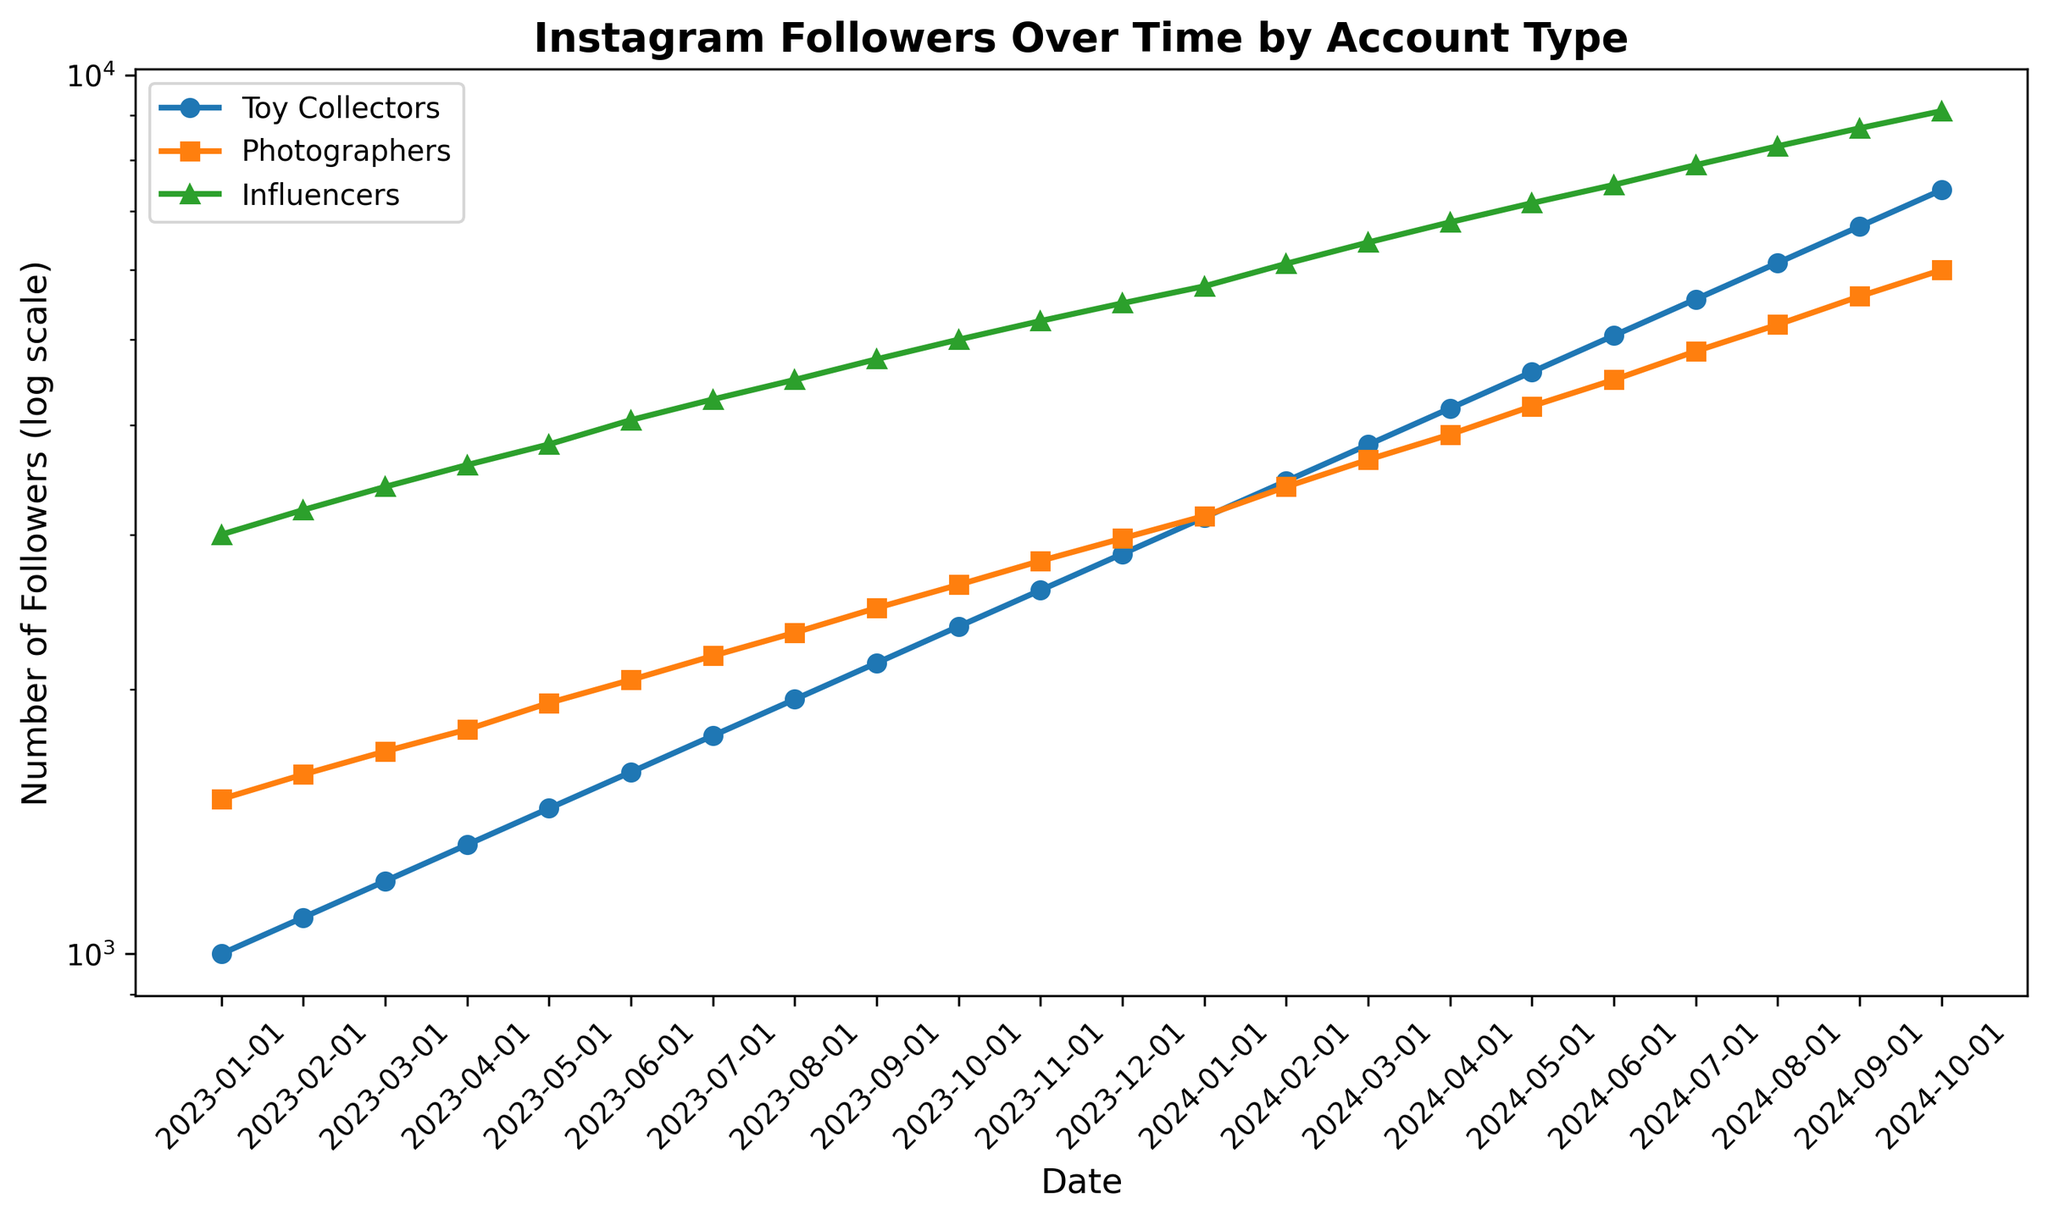How does the number of followers of Toy Collectors and Photographers compare in June 2024? To compare the number of followers of Toy Collectors and Photographers in June 2024, we look at their respective values. Toy Collectors have 5053 followers and Photographers have 4500 followers. By comparing these two values, we can see that Toy Collectors have more followers.
Answer: Toy Collectors have more followers Which account type experienced the highest growth rate from January 2023 to October 2024? To determine the highest growth rate, we calculate the percentage increase for each account type from January 2023 to October 2024. For Toy Collectors: ((7398 - 1000) / 1000) * 100 = 639.8%. For Photographers: ((6000 - 1500) / 1500) * 100 = 300%. For Influencers: ((9100 - 3000) / 3000) * 100 = 203.3%. Toy Collectors have the highest growth rate.
Answer: Toy Collectors What is the overall trend for the number of followers for all account types from January 2023 to October 2024? The trend can be observed by examining the slopes of the lines for each account type. All three lines show an upward trend on a log scale, indicating that the number of followers for Toy Collectors, Photographers, and Influencers is increasing over time.
Answer: Increasing On which month did Influencers cross the 5000 follower mark? Looking at the number of followers for Influencers, we see they crossed the 5000 follower mark in October 2023 when they reached 5000 followers.
Answer: October 2023 In which period did Toy Collectors see their highest monthly gain in followers? To find the highest monthly gain, we compare the increases in followers for each month. From February 2024 (3451) to March 2024 (3796) is an increase of 345 followers, which is the highest gain observed.
Answer: February to March 2024 Which account type has the steepest curve on the log scale plot? The steepness of the curve indicates the growth rate on a log scale. By observing the slopes visually, Toy Collectors have the steepest curve, indicating the fastest growth rate on a log scale.
Answer: Toy Collectors What is the difference in the number of followers between Photographers and Influencers in September 2023? In September 2023, Photographers have 2475 followers and Influencers have 4750 followers. The difference is 4750 - 2475 = 2275.
Answer: 2275 How many total followers did all account types have in January 2024? The total number of followers for all account types in January 2024 is the sum of Toy Collectors, Photographers, and Influencers. 3138 (Toy Collectors) + 3150 (Photographers) + 5750 (Influencers) = 12038.
Answer: 12038 Which account type surpassed 4000 followers first and in which month? To find which account type surpassed 4000 followers first, we observe the dates when follower counts exceed 4000. Influencers surpassed 4000 in June 2023 and Toy Collectors in June 2024. Photographers have not reached 4000 by October 2024.
Answer: Influencers, June 2023 